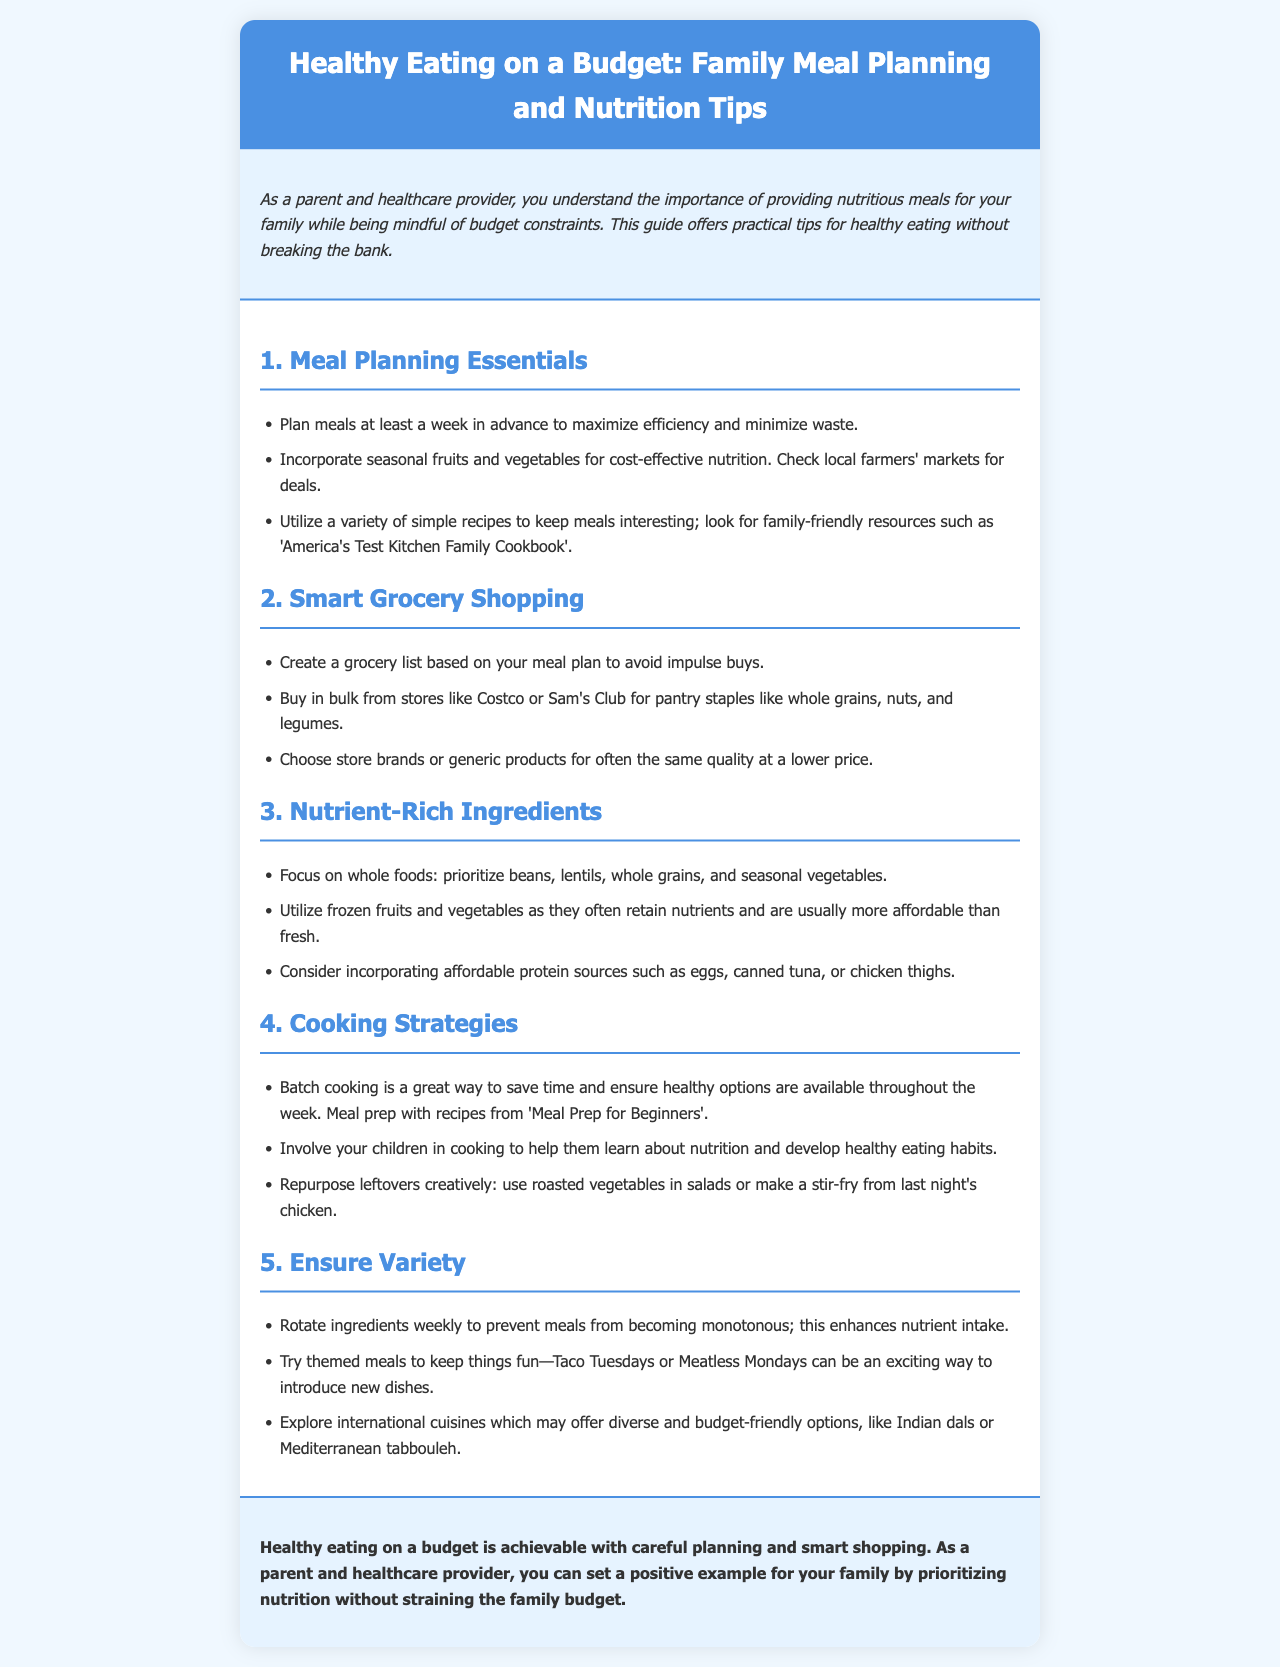What is the title of the brochure? The title is prominently displayed in the header of the document.
Answer: Healthy Eating on a Budget: Family Meal Planning and Nutrition Tips What is recommended to create before grocery shopping? This information is provided in the Smart Grocery Shopping section.
Answer: A grocery list Which cooking strategy is suggested to save time? This is mentioned in the Cooking Strategies section.
Answer: Batch cooking What type of foods should be prioritized according to Nutrient-Rich Ingredients? This information comes from the Nutrient-Rich Ingredients section.
Answer: Whole foods What themed meal is suggested for fun? This is mentioned in the Ensure Variety section.
Answer: Taco Tuesdays How many tips are provided in the Meal Planning Essentials section? The number of items in the Meal Planning Essentials section indicates this.
Answer: Three 